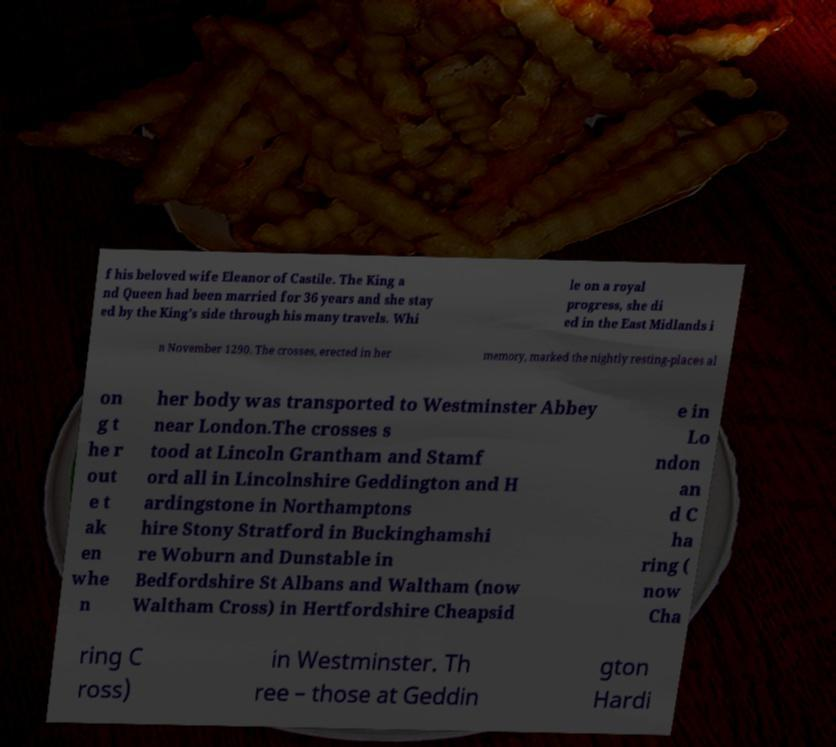Can you accurately transcribe the text from the provided image for me? f his beloved wife Eleanor of Castile. The King a nd Queen had been married for 36 years and she stay ed by the King’s side through his many travels. Whi le on a royal progress, she di ed in the East Midlands i n November 1290. The crosses, erected in her memory, marked the nightly resting-places al on g t he r out e t ak en whe n her body was transported to Westminster Abbey near London.The crosses s tood at Lincoln Grantham and Stamf ord all in Lincolnshire Geddington and H ardingstone in Northamptons hire Stony Stratford in Buckinghamshi re Woburn and Dunstable in Bedfordshire St Albans and Waltham (now Waltham Cross) in Hertfordshire Cheapsid e in Lo ndon an d C ha ring ( now Cha ring C ross) in Westminster. Th ree – those at Geddin gton Hardi 